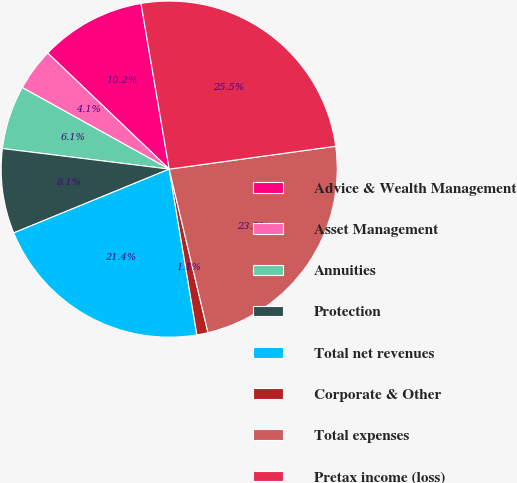<chart> <loc_0><loc_0><loc_500><loc_500><pie_chart><fcel>Advice & Wealth Management<fcel>Asset Management<fcel>Annuities<fcel>Protection<fcel>Total net revenues<fcel>Corporate & Other<fcel>Total expenses<fcel>Pretax income (loss)<nl><fcel>10.18%<fcel>4.07%<fcel>6.11%<fcel>8.15%<fcel>21.44%<fcel>1.07%<fcel>23.47%<fcel>25.51%<nl></chart> 